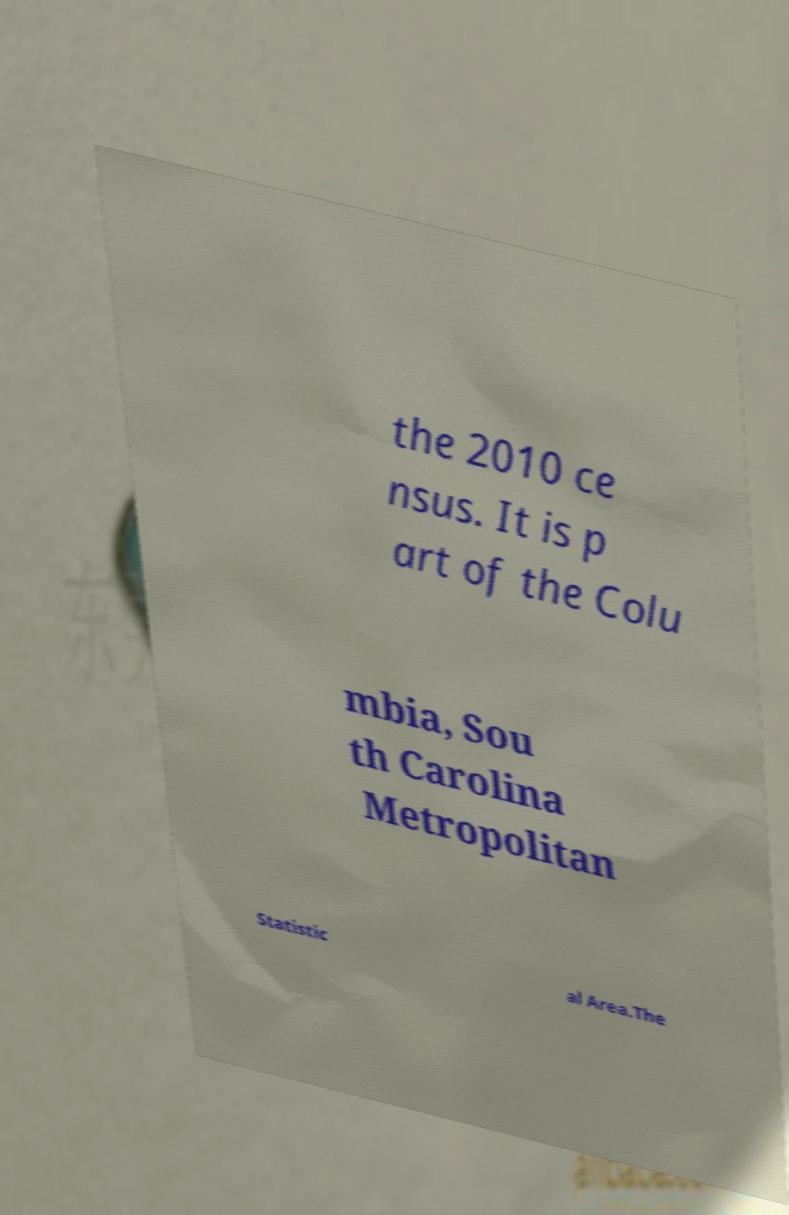Could you extract and type out the text from this image? the 2010 ce nsus. It is p art of the Colu mbia, Sou th Carolina Metropolitan Statistic al Area.The 